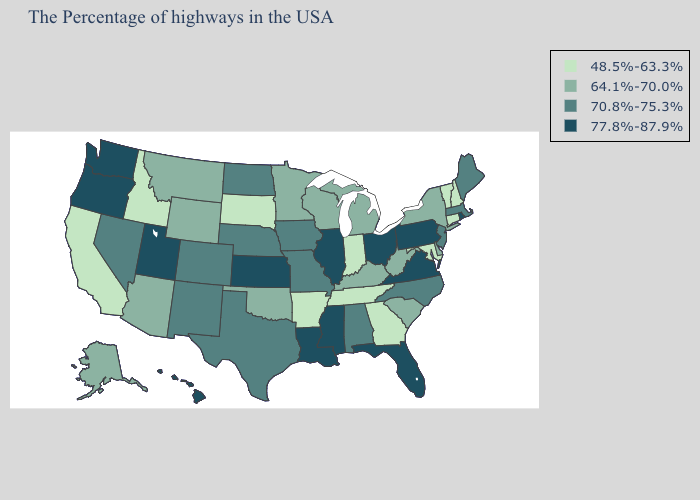Name the states that have a value in the range 77.8%-87.9%?
Answer briefly. Rhode Island, Pennsylvania, Virginia, Ohio, Florida, Illinois, Mississippi, Louisiana, Kansas, Utah, Washington, Oregon, Hawaii. What is the highest value in states that border Idaho?
Write a very short answer. 77.8%-87.9%. What is the value of New York?
Concise answer only. 64.1%-70.0%. What is the value of California?
Quick response, please. 48.5%-63.3%. Name the states that have a value in the range 77.8%-87.9%?
Be succinct. Rhode Island, Pennsylvania, Virginia, Ohio, Florida, Illinois, Mississippi, Louisiana, Kansas, Utah, Washington, Oregon, Hawaii. Name the states that have a value in the range 77.8%-87.9%?
Short answer required. Rhode Island, Pennsylvania, Virginia, Ohio, Florida, Illinois, Mississippi, Louisiana, Kansas, Utah, Washington, Oregon, Hawaii. Does Hawaii have the same value as West Virginia?
Write a very short answer. No. What is the highest value in the MidWest ?
Concise answer only. 77.8%-87.9%. Does Delaware have a lower value than Idaho?
Keep it brief. No. Which states have the lowest value in the USA?
Answer briefly. New Hampshire, Vermont, Connecticut, Maryland, Georgia, Indiana, Tennessee, Arkansas, South Dakota, Idaho, California. Which states have the lowest value in the MidWest?
Short answer required. Indiana, South Dakota. Name the states that have a value in the range 48.5%-63.3%?
Be succinct. New Hampshire, Vermont, Connecticut, Maryland, Georgia, Indiana, Tennessee, Arkansas, South Dakota, Idaho, California. Does Kansas have a lower value than Nevada?
Short answer required. No. What is the value of Virginia?
Short answer required. 77.8%-87.9%. Which states have the lowest value in the USA?
Short answer required. New Hampshire, Vermont, Connecticut, Maryland, Georgia, Indiana, Tennessee, Arkansas, South Dakota, Idaho, California. 